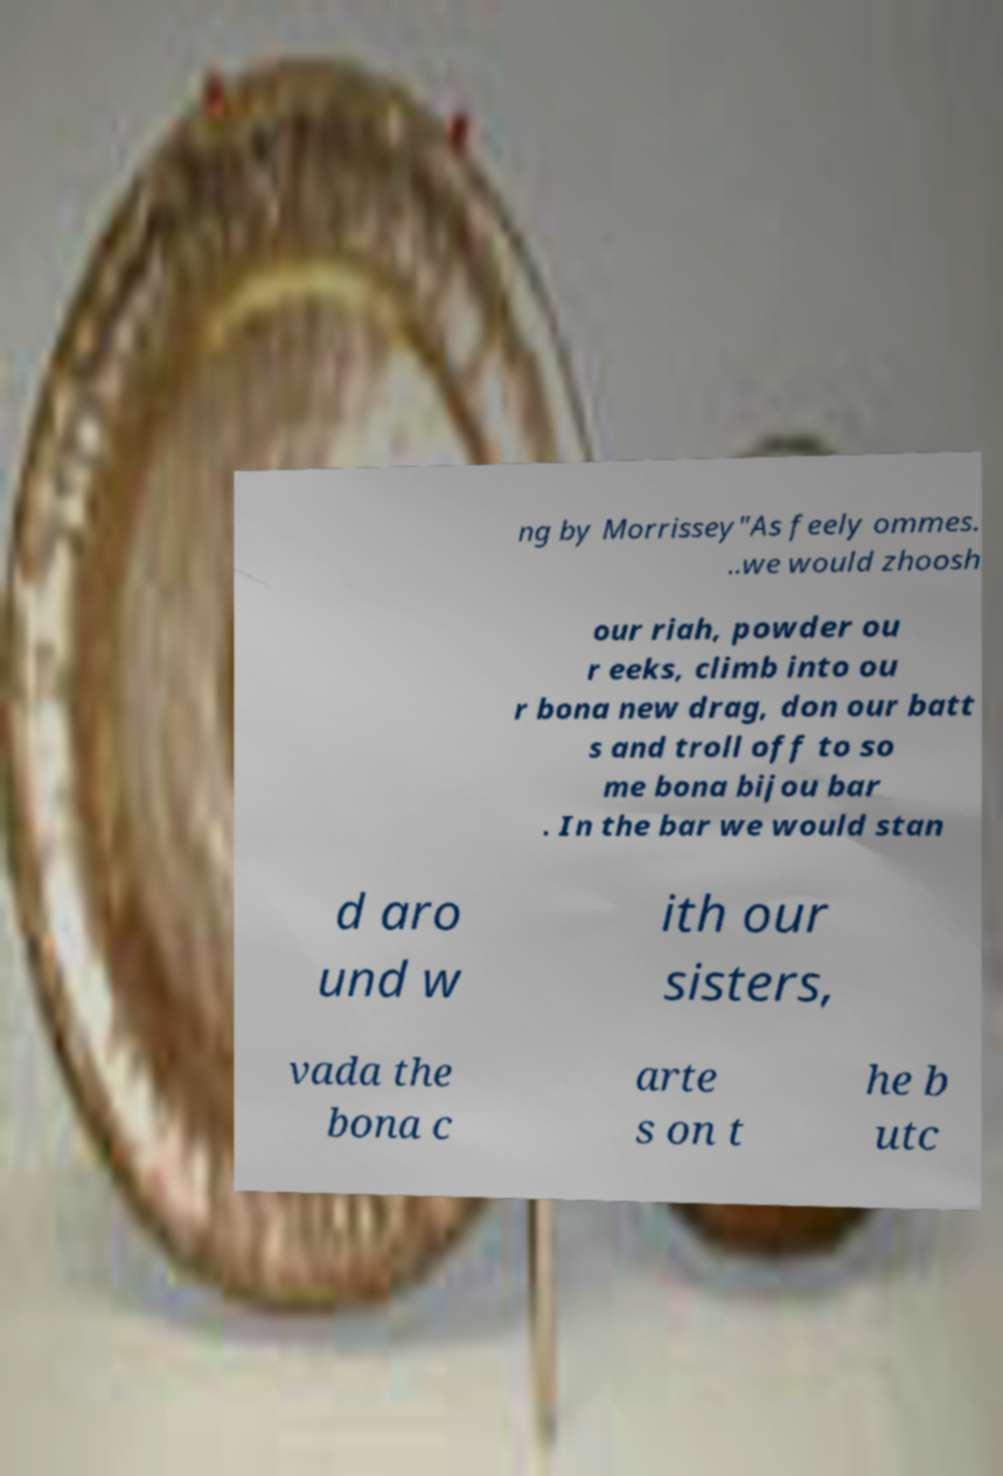Could you extract and type out the text from this image? ng by Morrissey"As feely ommes. ..we would zhoosh our riah, powder ou r eeks, climb into ou r bona new drag, don our batt s and troll off to so me bona bijou bar . In the bar we would stan d aro und w ith our sisters, vada the bona c arte s on t he b utc 